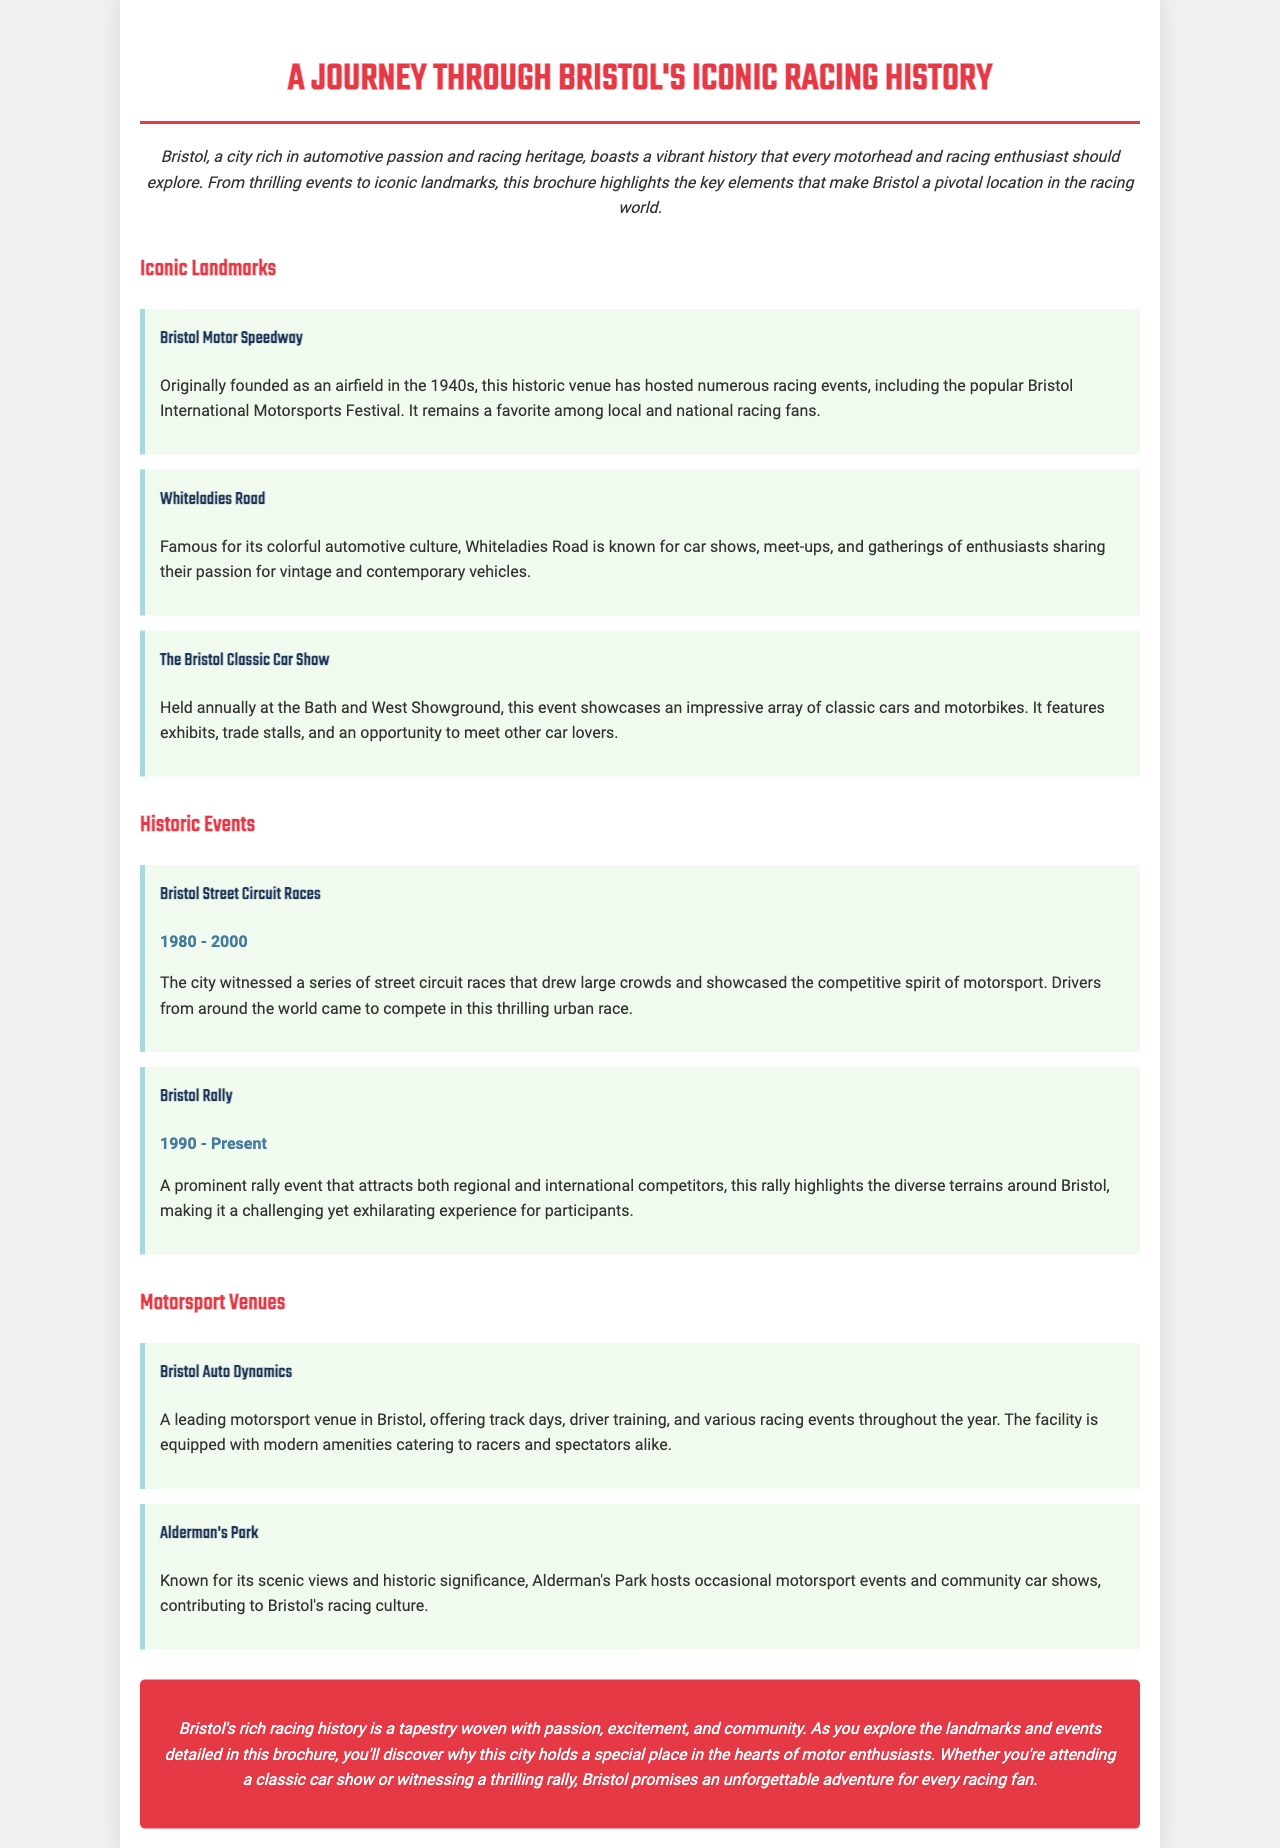What is the title of the brochure? The title of the brochure is mentioned at the top of the document.
Answer: A Journey Through Bristol's Iconic Racing History When was the Bristol Street Circuit Races held? The years during which the Bristol Street Circuit Races took place is found within the event description.
Answer: 1980 - 2000 Which venue is known for hosting the Bristol Classic Car Show? The document specifies the location of the Bristol Classic Car Show in the section about iconic landmarks.
Answer: Bath and West Showground What type of events does Bristol Auto Dynamics offer? The list of activities and events at Bristol Auto Dynamics is included in the motorsport venues section.
Answer: Track days, driver training, and various racing events What is the ongoing rally event mentioned in the brochure? The current rally event that is highlighted can be found in the historic events section.
Answer: Bristol Rally Which landmark is famous for colorful automotive culture? The landmark known for its automotive culture is indicated in the iconic landmarks section.
Answer: Whiteladies Road What is the color of the conclusion section? The description of the conclusion section includes its background color.
Answer: Red How long has the Bristol Rally been taking place? The duration of the Bristol Rally is mentioned directly in the event description.
Answer: 1990 - Present What is the main theme of the brochure? The main theme is presented in the introduction and conclusion sections of the document.
Answer: Bristol's racing history 